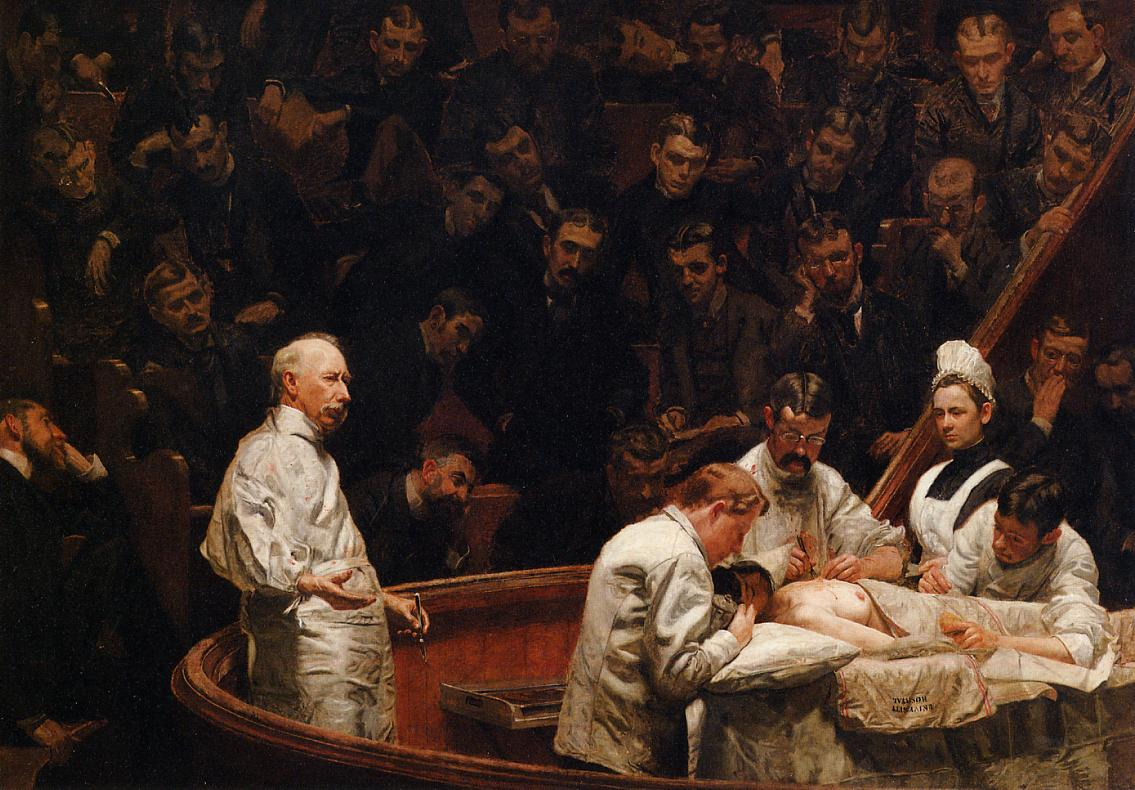Can you describe the emotions portrayed by the onlookers? The onlookers exhibit a range of emotions, primarily focusing on intense concentration and curiosity. Their expressions vary from contemplative to slightly anxious, reflecting the gravity of the surgical procedure they are witnessing. Some faces may show signs of anticipation, while others seem deeply absorbed in studying the technique and outcome. The overall mood among the onlookers is one of serious engagement, underscoring the educational importance of the event they are observing. What role do the dark hues play in the painting's composition? The dark hues in the painting serve to create a dramatic and focused atmosphere. They help in directing the viewer's attention to the central figures—the surgeons and the patient—by contrasting sharply with their white gowns. This use of color not only emphasizes the seriousness and intensity of the surgical scene but also creates a stark visual hierarchy that highlights the clinical actions against the somber background. The darkness adds depth and a sense of gravity, enhancing the historical and educational significance of the moment captured. Think about what might have been happening outside the room where this surgery is taking place. Outside the room, life in the late 19th century would be bustling with the daily activities of a growing urban environment. The hospital might be surrounded by carriages, street vendors, and pedestrians going about their day. Medical advancements and scientific discoveries were rapidly progressing, and the general public's interest in these fields was high. The hospital staff would be tending to other patients, dealing with emergencies, and performing routine medical duties. The world beyond the operating theater would be a mix of industrial progress and the challenges of a society on the cusp of modernity. Describe a realistic scenario depicted in the image. A realistic scenario depicted in the image is a surgical demonstration at a teaching hospital during the late 19th century. The surgeons, experienced and skilled, are performing an operation in front of an audience of medical students and fellow doctors. The patient, likely undergoing a critical procedure, lies on the table while the primary surgeon makes incisions with the assistance of his colleagues. The onlookers, eager to learn, watch intently, taking mental notes to better understand the intricacies of surgical techniques. The environment is serious and focused, highlighting the educational and medical practices of the time. Imagine the impact this scene would have on a new medical student. For a new medical student, witnessing this scene would be awe-inspiring and possibly overwhelming. The intense focus of the surgeons, the gravity of the procedure, and the attentive audience would underscore the high stakes and responsibility that comes with the profession. The student might feel a mix of excitement and anxiety, motivated by the desire to acquire such skills and meet the expectations of the field. This experience would highlight the importance of their education and the profound impact they can have on lives, instilling a deep respect for the complexities and demands of medical practice. 